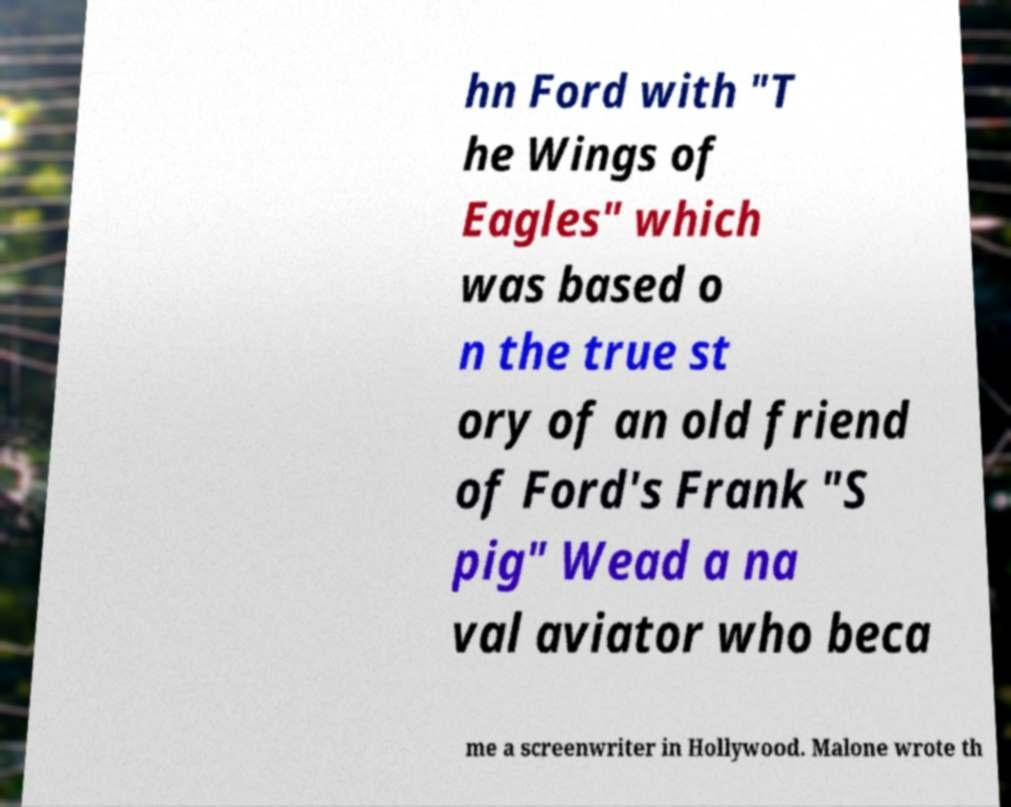There's text embedded in this image that I need extracted. Can you transcribe it verbatim? hn Ford with "T he Wings of Eagles" which was based o n the true st ory of an old friend of Ford's Frank "S pig" Wead a na val aviator who beca me a screenwriter in Hollywood. Malone wrote th 